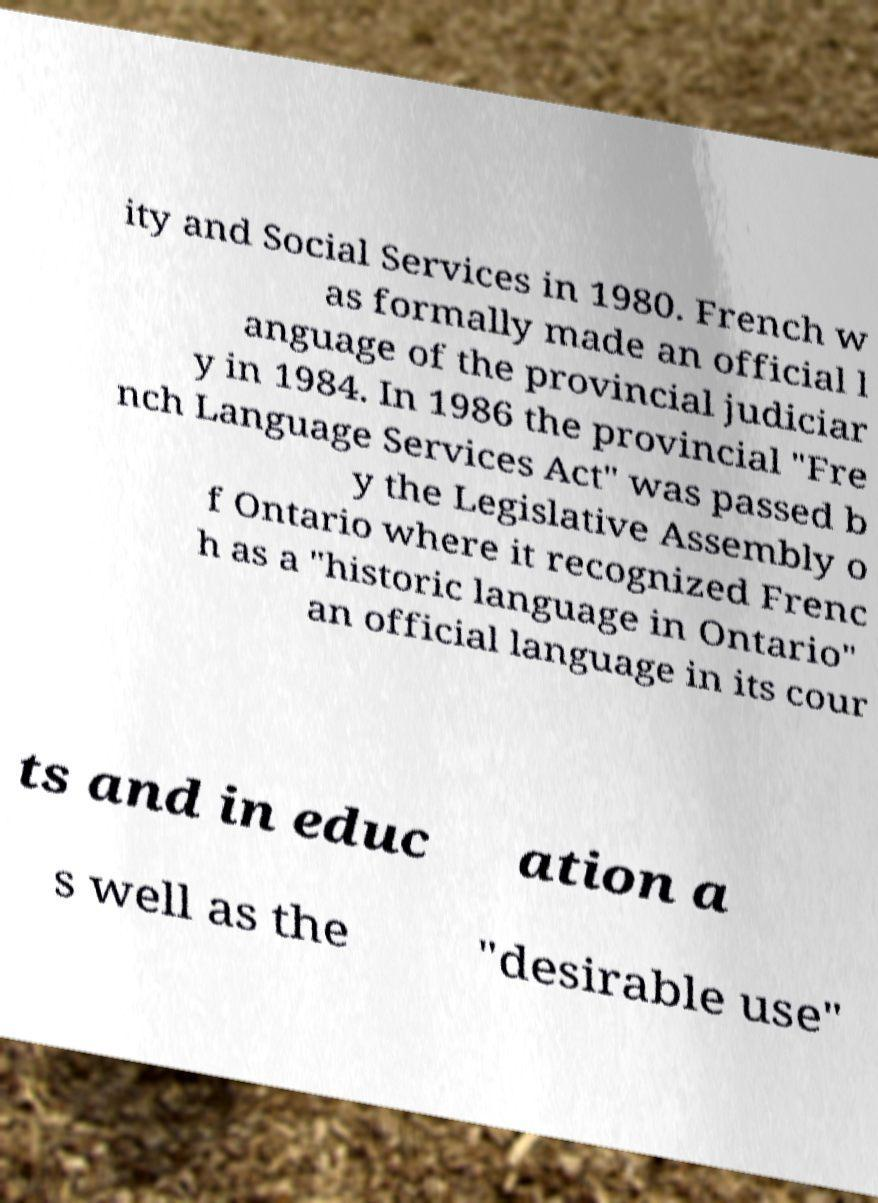Could you extract and type out the text from this image? ity and Social Services in 1980. French w as formally made an official l anguage of the provincial judiciar y in 1984. In 1986 the provincial "Fre nch Language Services Act" was passed b y the Legislative Assembly o f Ontario where it recognized Frenc h as a "historic language in Ontario" an official language in its cour ts and in educ ation a s well as the "desirable use" 